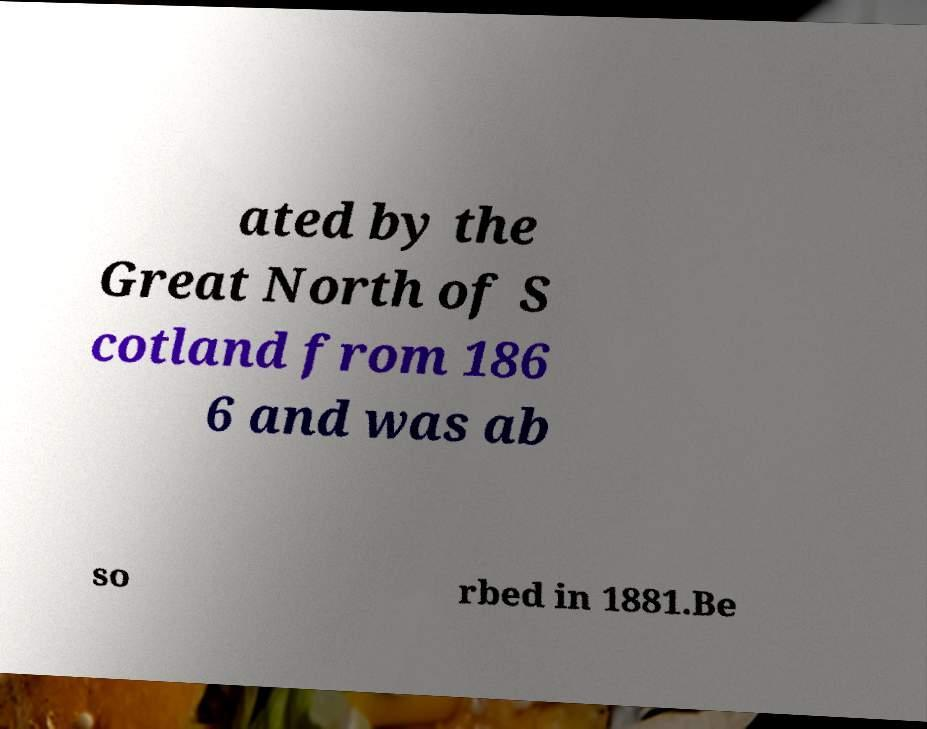Could you extract and type out the text from this image? ated by the Great North of S cotland from 186 6 and was ab so rbed in 1881.Be 